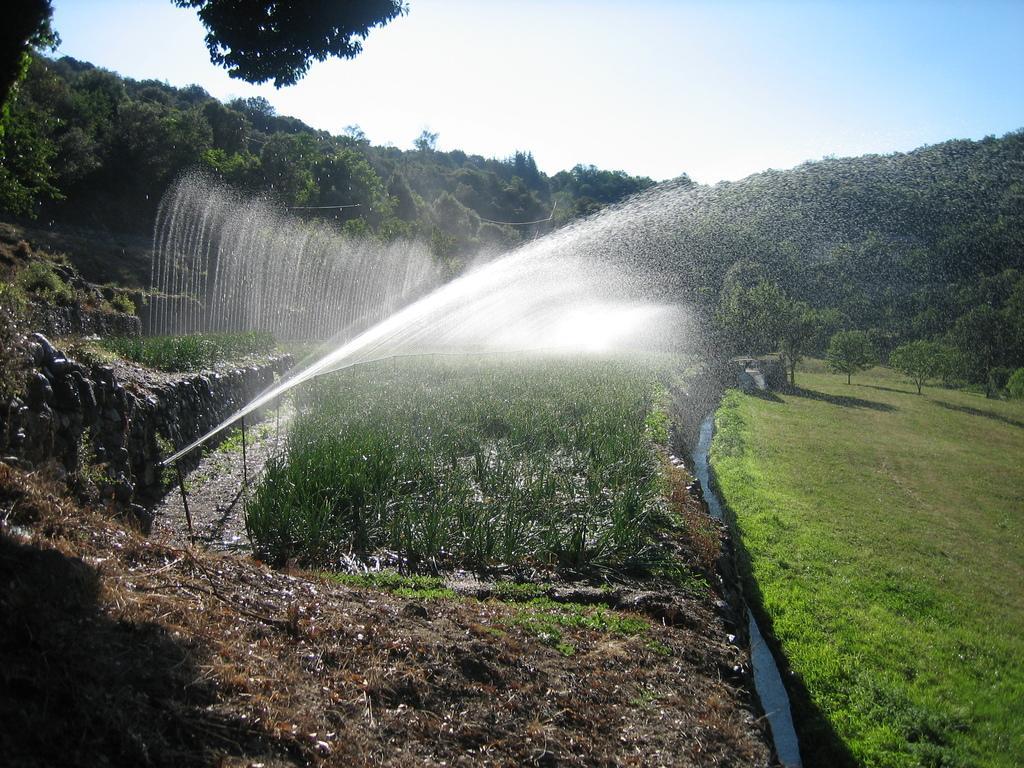In one or two sentences, can you explain what this image depicts? In this picture, we see the water sprinklers. Beside that, there are plants. At the bottom, we see the grass and the twigs. On the right side, we see grass and water. There are trees in the background. At the top, we see the sky. 